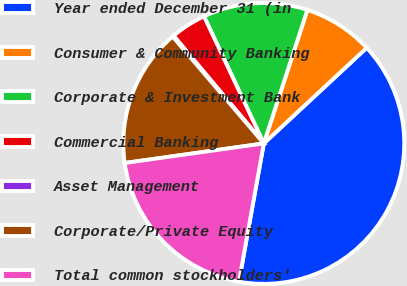Convert chart. <chart><loc_0><loc_0><loc_500><loc_500><pie_chart><fcel>Year ended December 31 (in<fcel>Consumer & Community Banking<fcel>Corporate & Investment Bank<fcel>Commercial Banking<fcel>Asset Management<fcel>Corporate/Private Equity<fcel>Total common stockholders'<nl><fcel>39.75%<fcel>8.06%<fcel>12.02%<fcel>4.1%<fcel>0.14%<fcel>15.98%<fcel>19.94%<nl></chart> 